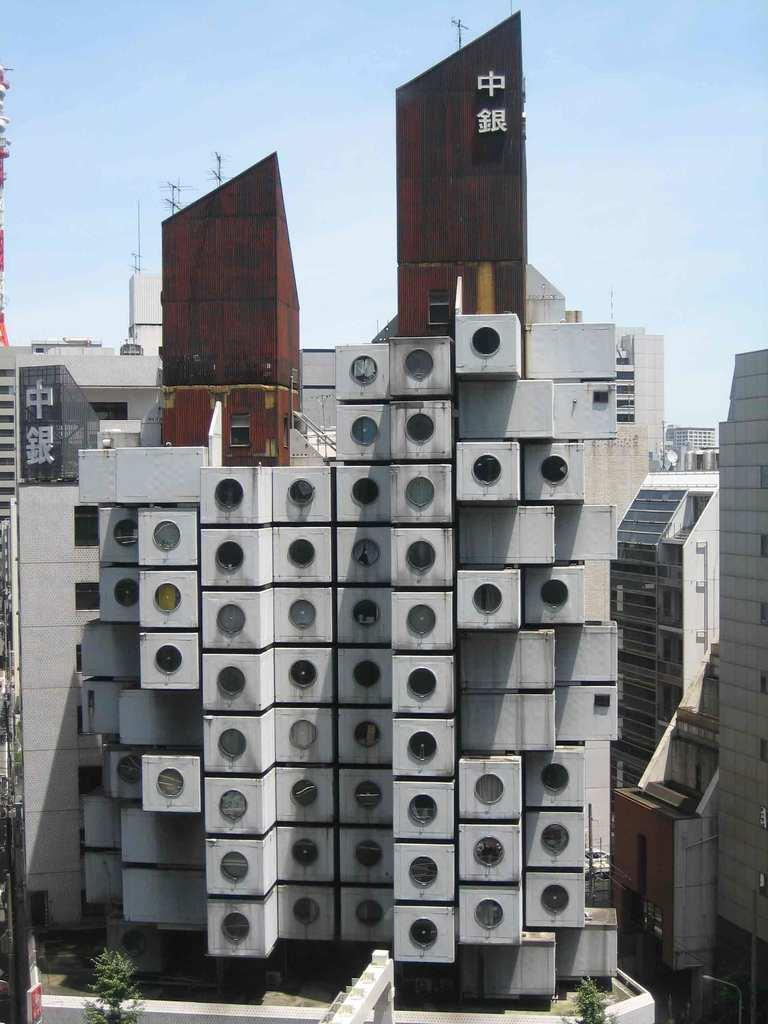<image>
Provide a brief description of the given image. A large building that has korean characters on it 